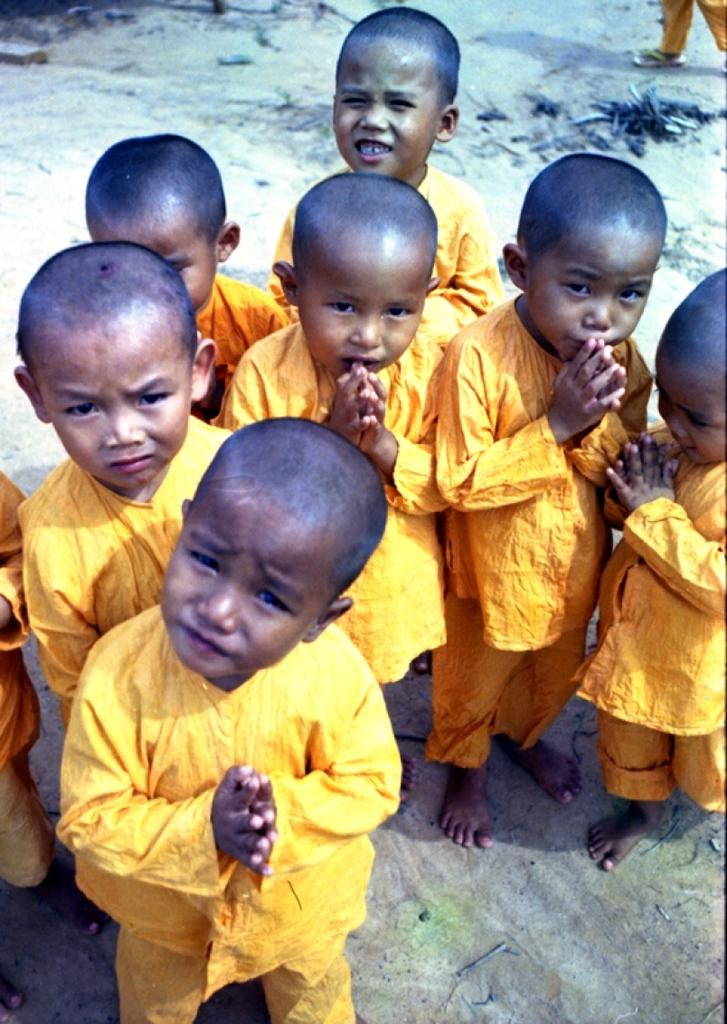What is the main subject of the image? The main subject of the image is a group of kids. What is the position of the kids in the image? The kids are standing on the ground. What type of rhythm can be heard coming from the boys in the image? There is no indication in the image that the kids are making any sounds or rhythms, so it's not possible to determine what, if any, rhythm might be heard. 